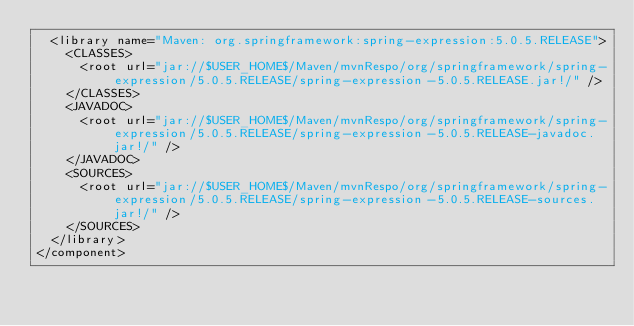<code> <loc_0><loc_0><loc_500><loc_500><_XML_>  <library name="Maven: org.springframework:spring-expression:5.0.5.RELEASE">
    <CLASSES>
      <root url="jar://$USER_HOME$/Maven/mvnRespo/org/springframework/spring-expression/5.0.5.RELEASE/spring-expression-5.0.5.RELEASE.jar!/" />
    </CLASSES>
    <JAVADOC>
      <root url="jar://$USER_HOME$/Maven/mvnRespo/org/springframework/spring-expression/5.0.5.RELEASE/spring-expression-5.0.5.RELEASE-javadoc.jar!/" />
    </JAVADOC>
    <SOURCES>
      <root url="jar://$USER_HOME$/Maven/mvnRespo/org/springframework/spring-expression/5.0.5.RELEASE/spring-expression-5.0.5.RELEASE-sources.jar!/" />
    </SOURCES>
  </library>
</component></code> 